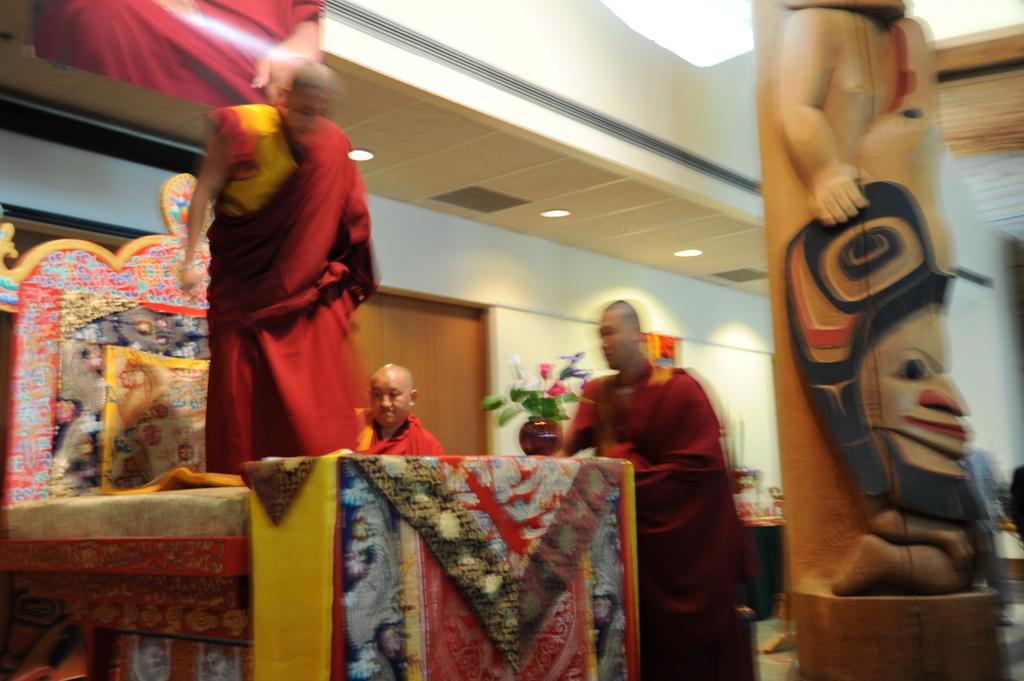Please provide a concise description of this image. In this image three people are standing, one person is standing on a bed with carpets. I can see a pillar or a wooden statue on the right hand side of the image. I can see a potted plant in the center of the image.  